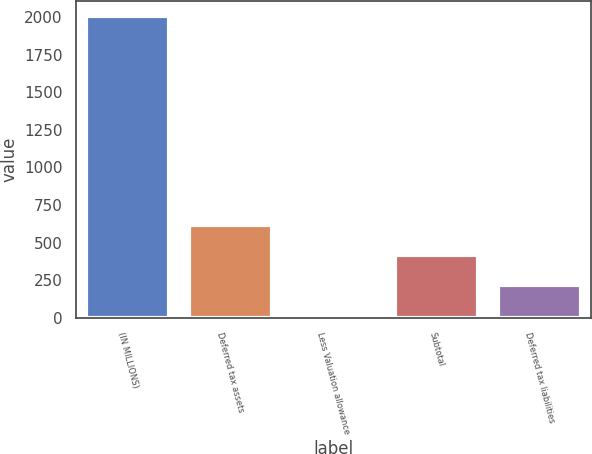Convert chart to OTSL. <chart><loc_0><loc_0><loc_500><loc_500><bar_chart><fcel>(IN MILLIONS)<fcel>Deferred tax assets<fcel>Less Valuation allowance<fcel>Subtotal<fcel>Deferred tax liabilities<nl><fcel>2005<fcel>614.8<fcel>19<fcel>416.2<fcel>217.6<nl></chart> 